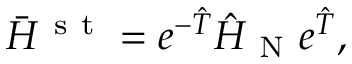Convert formula to latex. <formula><loc_0><loc_0><loc_500><loc_500>\ B a r { H } ^ { s t } = e ^ { - \hat { T } } \hat { H } _ { N } e ^ { \hat { T } } ,</formula> 